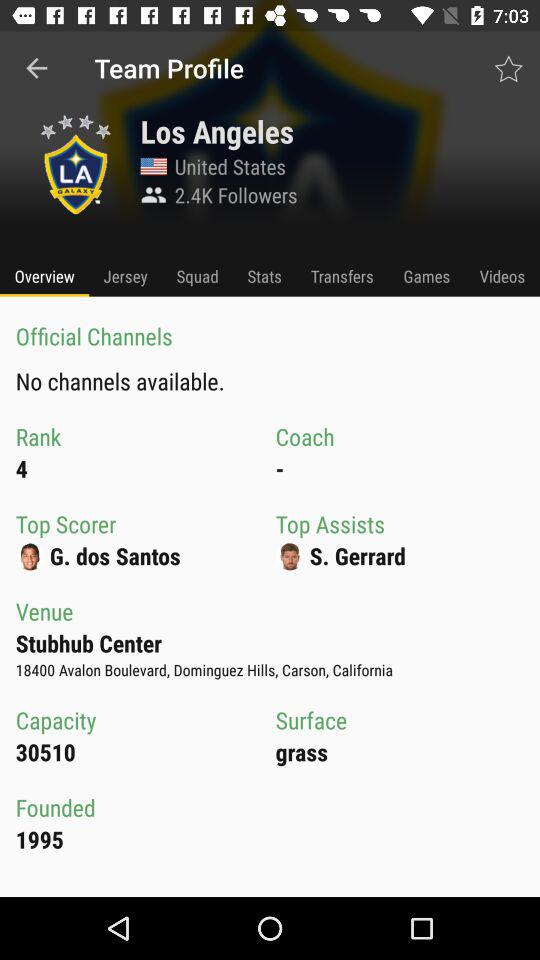How much is the capacity? The capacity is 30510. 